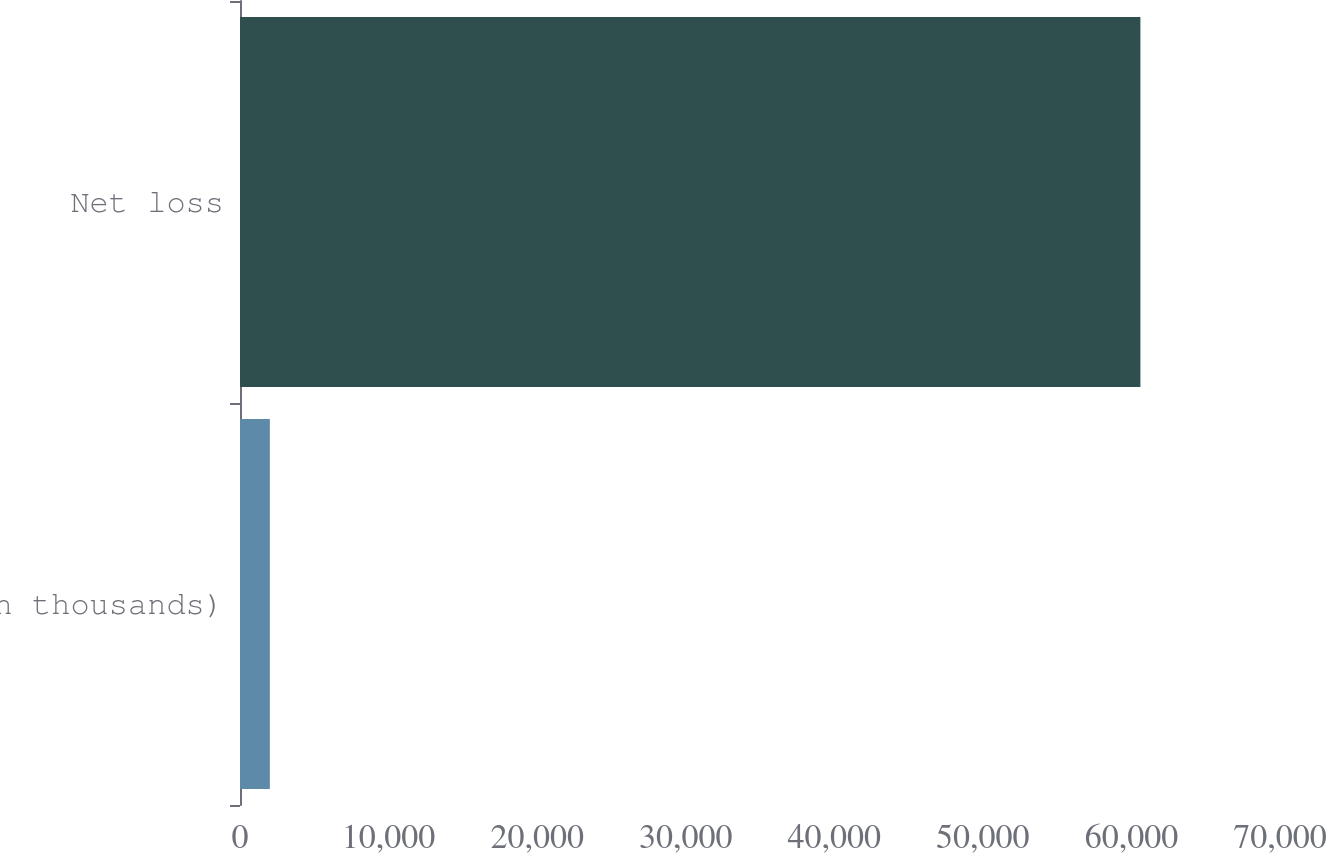<chart> <loc_0><loc_0><loc_500><loc_500><bar_chart><fcel>(in thousands)<fcel>Net loss<nl><fcel>2009<fcel>60604<nl></chart> 